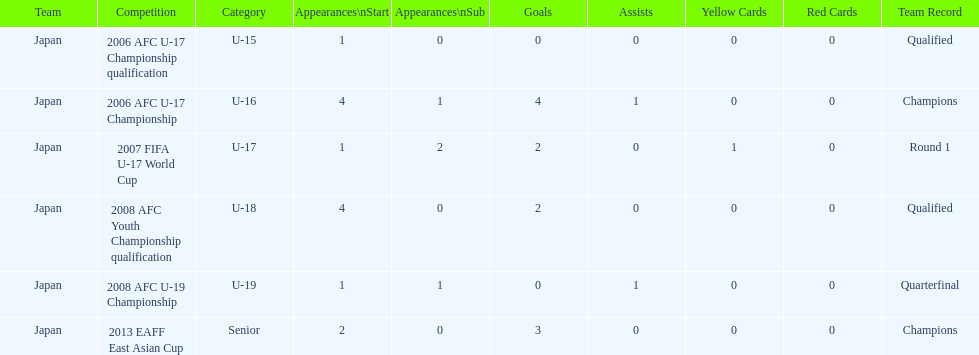What was yoichiro kakitani's first substantial tournament? 2006 AFC U-17 Championship qualification. 